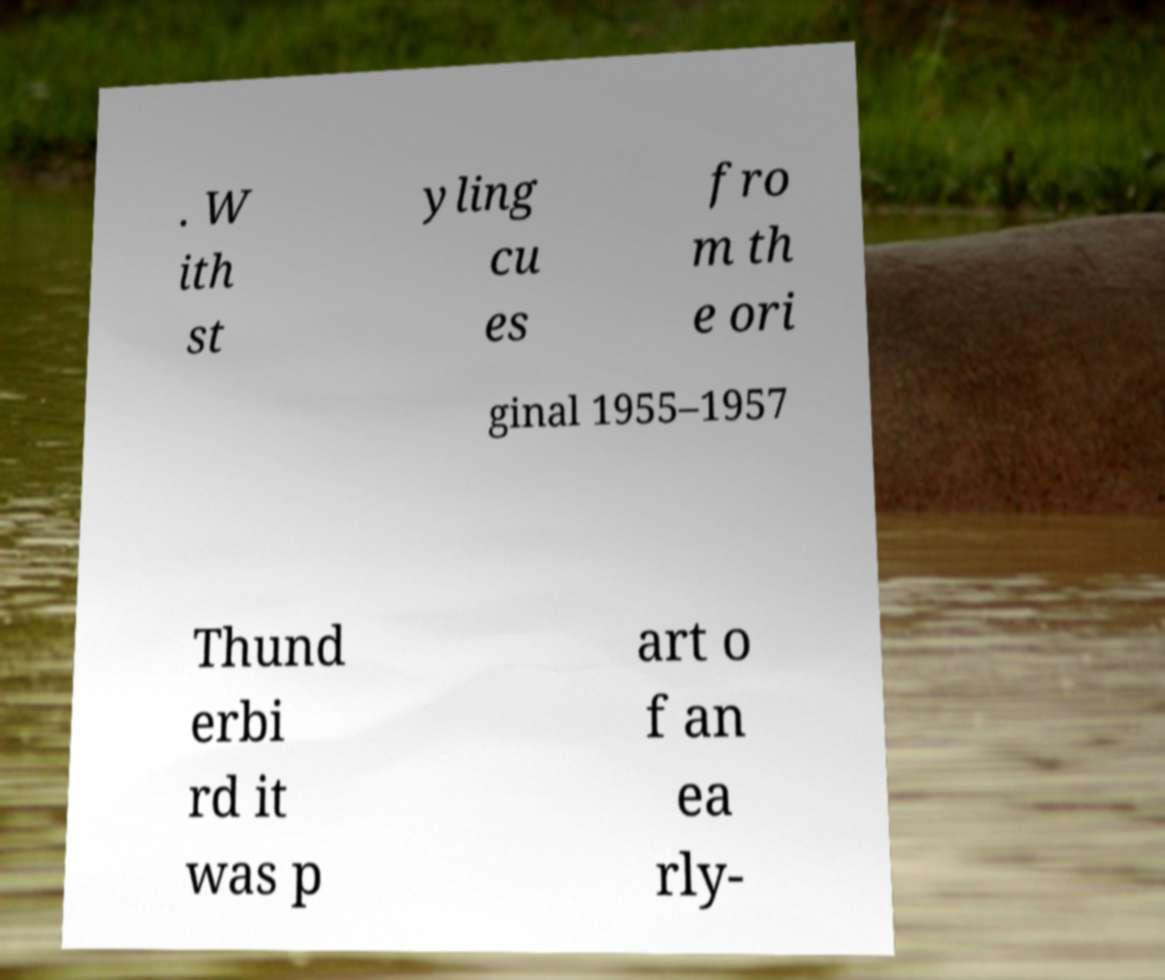What messages or text are displayed in this image? I need them in a readable, typed format. . W ith st yling cu es fro m th e ori ginal 1955–1957 Thund erbi rd it was p art o f an ea rly- 